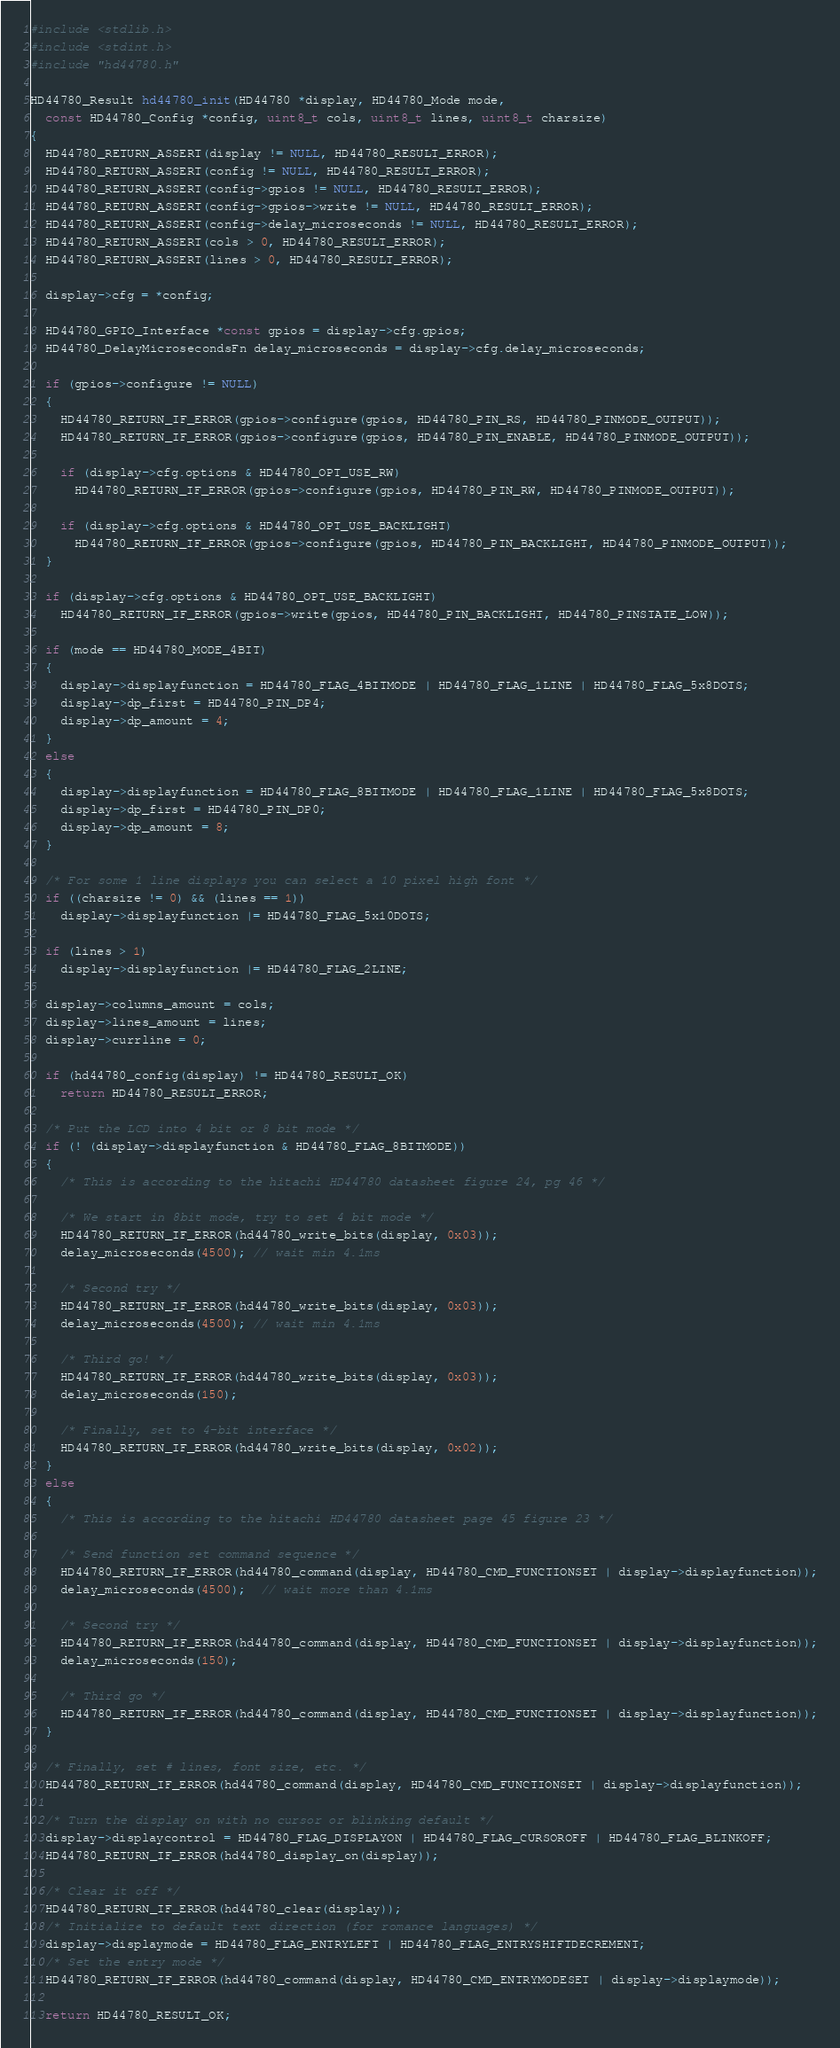Convert code to text. <code><loc_0><loc_0><loc_500><loc_500><_C_>#include <stdlib.h>
#include <stdint.h>
#include "hd44780.h"

HD44780_Result hd44780_init(HD44780 *display, HD44780_Mode mode,
  const HD44780_Config *config, uint8_t cols, uint8_t lines, uint8_t charsize)
{
  HD44780_RETURN_ASSERT(display != NULL, HD44780_RESULT_ERROR);
  HD44780_RETURN_ASSERT(config != NULL, HD44780_RESULT_ERROR);
  HD44780_RETURN_ASSERT(config->gpios != NULL, HD44780_RESULT_ERROR);
  HD44780_RETURN_ASSERT(config->gpios->write != NULL, HD44780_RESULT_ERROR);
  HD44780_RETURN_ASSERT(config->delay_microseconds != NULL, HD44780_RESULT_ERROR);
  HD44780_RETURN_ASSERT(cols > 0, HD44780_RESULT_ERROR);
  HD44780_RETURN_ASSERT(lines > 0, HD44780_RESULT_ERROR);

  display->cfg = *config;

  HD44780_GPIO_Interface *const gpios = display->cfg.gpios;
  HD44780_DelayMicrosecondsFn delay_microseconds = display->cfg.delay_microseconds;

  if (gpios->configure != NULL)
  {
    HD44780_RETURN_IF_ERROR(gpios->configure(gpios, HD44780_PIN_RS, HD44780_PINMODE_OUTPUT));
    HD44780_RETURN_IF_ERROR(gpios->configure(gpios, HD44780_PIN_ENABLE, HD44780_PINMODE_OUTPUT));

    if (display->cfg.options & HD44780_OPT_USE_RW)
      HD44780_RETURN_IF_ERROR(gpios->configure(gpios, HD44780_PIN_RW, HD44780_PINMODE_OUTPUT));

    if (display->cfg.options & HD44780_OPT_USE_BACKLIGHT)
      HD44780_RETURN_IF_ERROR(gpios->configure(gpios, HD44780_PIN_BACKLIGHT, HD44780_PINMODE_OUTPUT));
  }

  if (display->cfg.options & HD44780_OPT_USE_BACKLIGHT)
    HD44780_RETURN_IF_ERROR(gpios->write(gpios, HD44780_PIN_BACKLIGHT, HD44780_PINSTATE_LOW));

  if (mode == HD44780_MODE_4BIT)
  {
    display->displayfunction = HD44780_FLAG_4BITMODE | HD44780_FLAG_1LINE | HD44780_FLAG_5x8DOTS;
    display->dp_first = HD44780_PIN_DP4;
    display->dp_amount = 4;
  }
  else
  {
    display->displayfunction = HD44780_FLAG_8BITMODE | HD44780_FLAG_1LINE | HD44780_FLAG_5x8DOTS;
    display->dp_first = HD44780_PIN_DP0;
    display->dp_amount = 8;
  }

  /* For some 1 line displays you can select a 10 pixel high font */
  if ((charsize != 0) && (lines == 1))
    display->displayfunction |= HD44780_FLAG_5x10DOTS;

  if (lines > 1)
    display->displayfunction |= HD44780_FLAG_2LINE;

  display->columns_amount = cols;
  display->lines_amount = lines;
  display->currline = 0;

  if (hd44780_config(display) != HD44780_RESULT_OK)
    return HD44780_RESULT_ERROR;

  /* Put the LCD into 4 bit or 8 bit mode */
  if (! (display->displayfunction & HD44780_FLAG_8BITMODE))
  {
    /* This is according to the hitachi HD44780 datasheet figure 24, pg 46 */

    /* We start in 8bit mode, try to set 4 bit mode */
    HD44780_RETURN_IF_ERROR(hd44780_write_bits(display, 0x03));
    delay_microseconds(4500); // wait min 4.1ms

    /* Second try */
    HD44780_RETURN_IF_ERROR(hd44780_write_bits(display, 0x03));
    delay_microseconds(4500); // wait min 4.1ms

    /* Third go! */
    HD44780_RETURN_IF_ERROR(hd44780_write_bits(display, 0x03));
    delay_microseconds(150);

    /* Finally, set to 4-bit interface */
    HD44780_RETURN_IF_ERROR(hd44780_write_bits(display, 0x02));
  }
  else
  {
    /* This is according to the hitachi HD44780 datasheet page 45 figure 23 */

    /* Send function set command sequence */
    HD44780_RETURN_IF_ERROR(hd44780_command(display, HD44780_CMD_FUNCTIONSET | display->displayfunction));
    delay_microseconds(4500);  // wait more than 4.1ms

    /* Second try */
    HD44780_RETURN_IF_ERROR(hd44780_command(display, HD44780_CMD_FUNCTIONSET | display->displayfunction));
    delay_microseconds(150);

    /* Third go */
    HD44780_RETURN_IF_ERROR(hd44780_command(display, HD44780_CMD_FUNCTIONSET | display->displayfunction));
  }

  /* Finally, set # lines, font size, etc. */
  HD44780_RETURN_IF_ERROR(hd44780_command(display, HD44780_CMD_FUNCTIONSET | display->displayfunction));

  /* Turn the display on with no cursor or blinking default */
  display->displaycontrol = HD44780_FLAG_DISPLAYON | HD44780_FLAG_CURSOROFF | HD44780_FLAG_BLINKOFF;
  HD44780_RETURN_IF_ERROR(hd44780_display_on(display));

  /* Clear it off */
  HD44780_RETURN_IF_ERROR(hd44780_clear(display));
  /* Initialize to default text direction (for romance languages) */
  display->displaymode = HD44780_FLAG_ENTRYLEFT | HD44780_FLAG_ENTRYSHIFTDECREMENT;
  /* Set the entry mode */
  HD44780_RETURN_IF_ERROR(hd44780_command(display, HD44780_CMD_ENTRYMODESET | display->displaymode));

  return HD44780_RESULT_OK;
</code> 